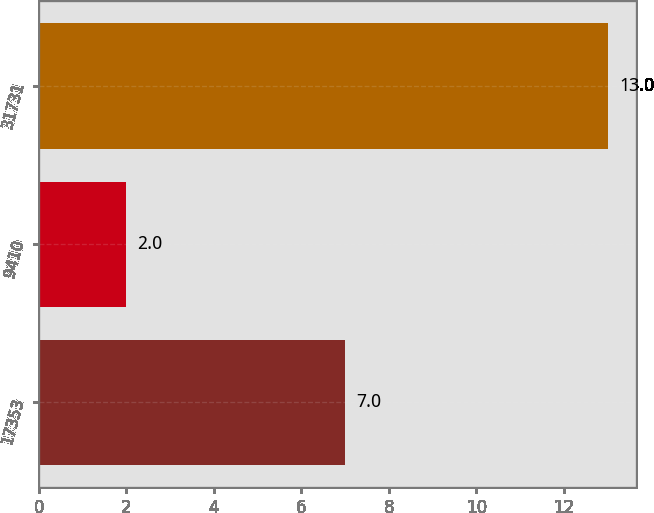Convert chart. <chart><loc_0><loc_0><loc_500><loc_500><bar_chart><fcel>17353<fcel>9410<fcel>31731<nl><fcel>7<fcel>2<fcel>13<nl></chart> 